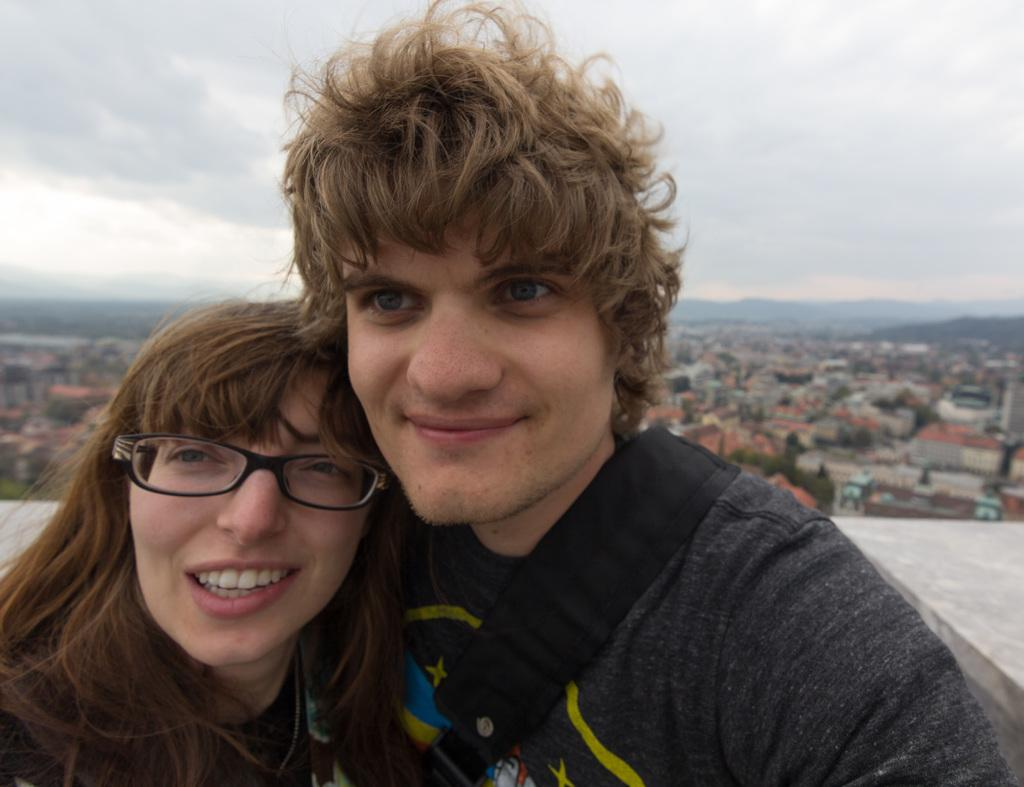Who are the people in the image? There is a lady and a man in the image. What are the lady and the man doing in the image? Both the lady and the man are standing. What expressions do the lady and the man have in the image? Both the lady and the man are smiling. What can be seen in the background of the image? There are buildings, trees, and a wall in the background of the image. What is visible at the top of the image? The sky is visible at the top of the image. What type of blade is being used by the lady in the image? There is no blade present in the image; the lady and the man are simply standing and smiling. 